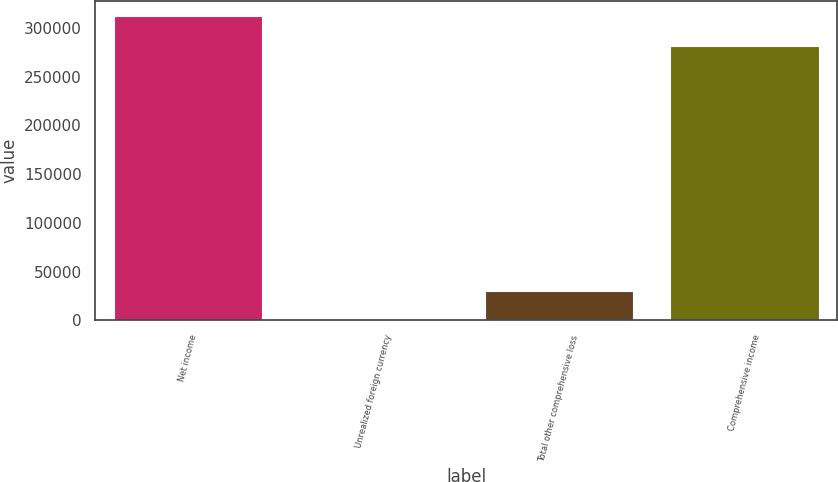<chart> <loc_0><loc_0><loc_500><loc_500><bar_chart><fcel>Net income<fcel>Unrealized foreign currency<fcel>Total other comprehensive loss<fcel>Comprehensive income<nl><fcel>312268<fcel>176<fcel>30591.4<fcel>281853<nl></chart> 